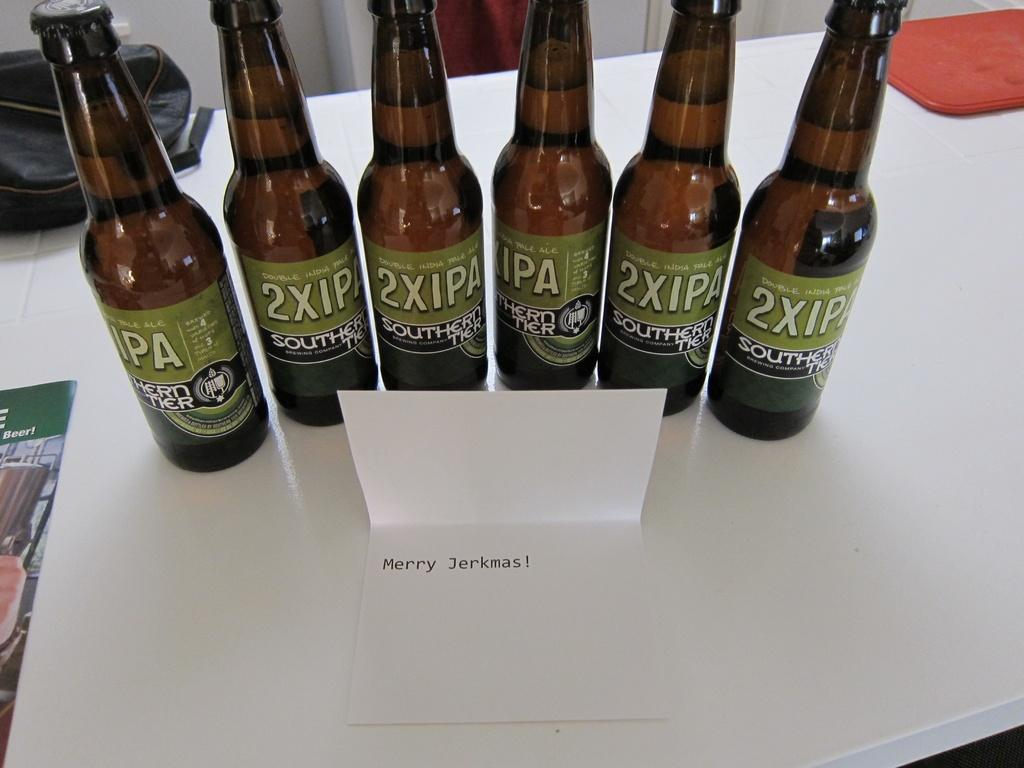Provide a one-sentence caption for the provided image. Several bottles of 2XIPA are lined up near a card that says Merry Jerkmas!. 